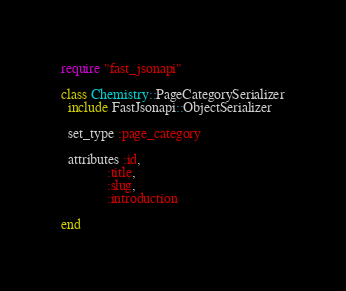<code> <loc_0><loc_0><loc_500><loc_500><_Ruby_>require "fast_jsonapi"

class Chemistry::PageCategorySerializer
  include FastJsonapi::ObjectSerializer

  set_type :page_category

  attributes :id,
             :title,
             :slug,
             :introduction

end
</code> 